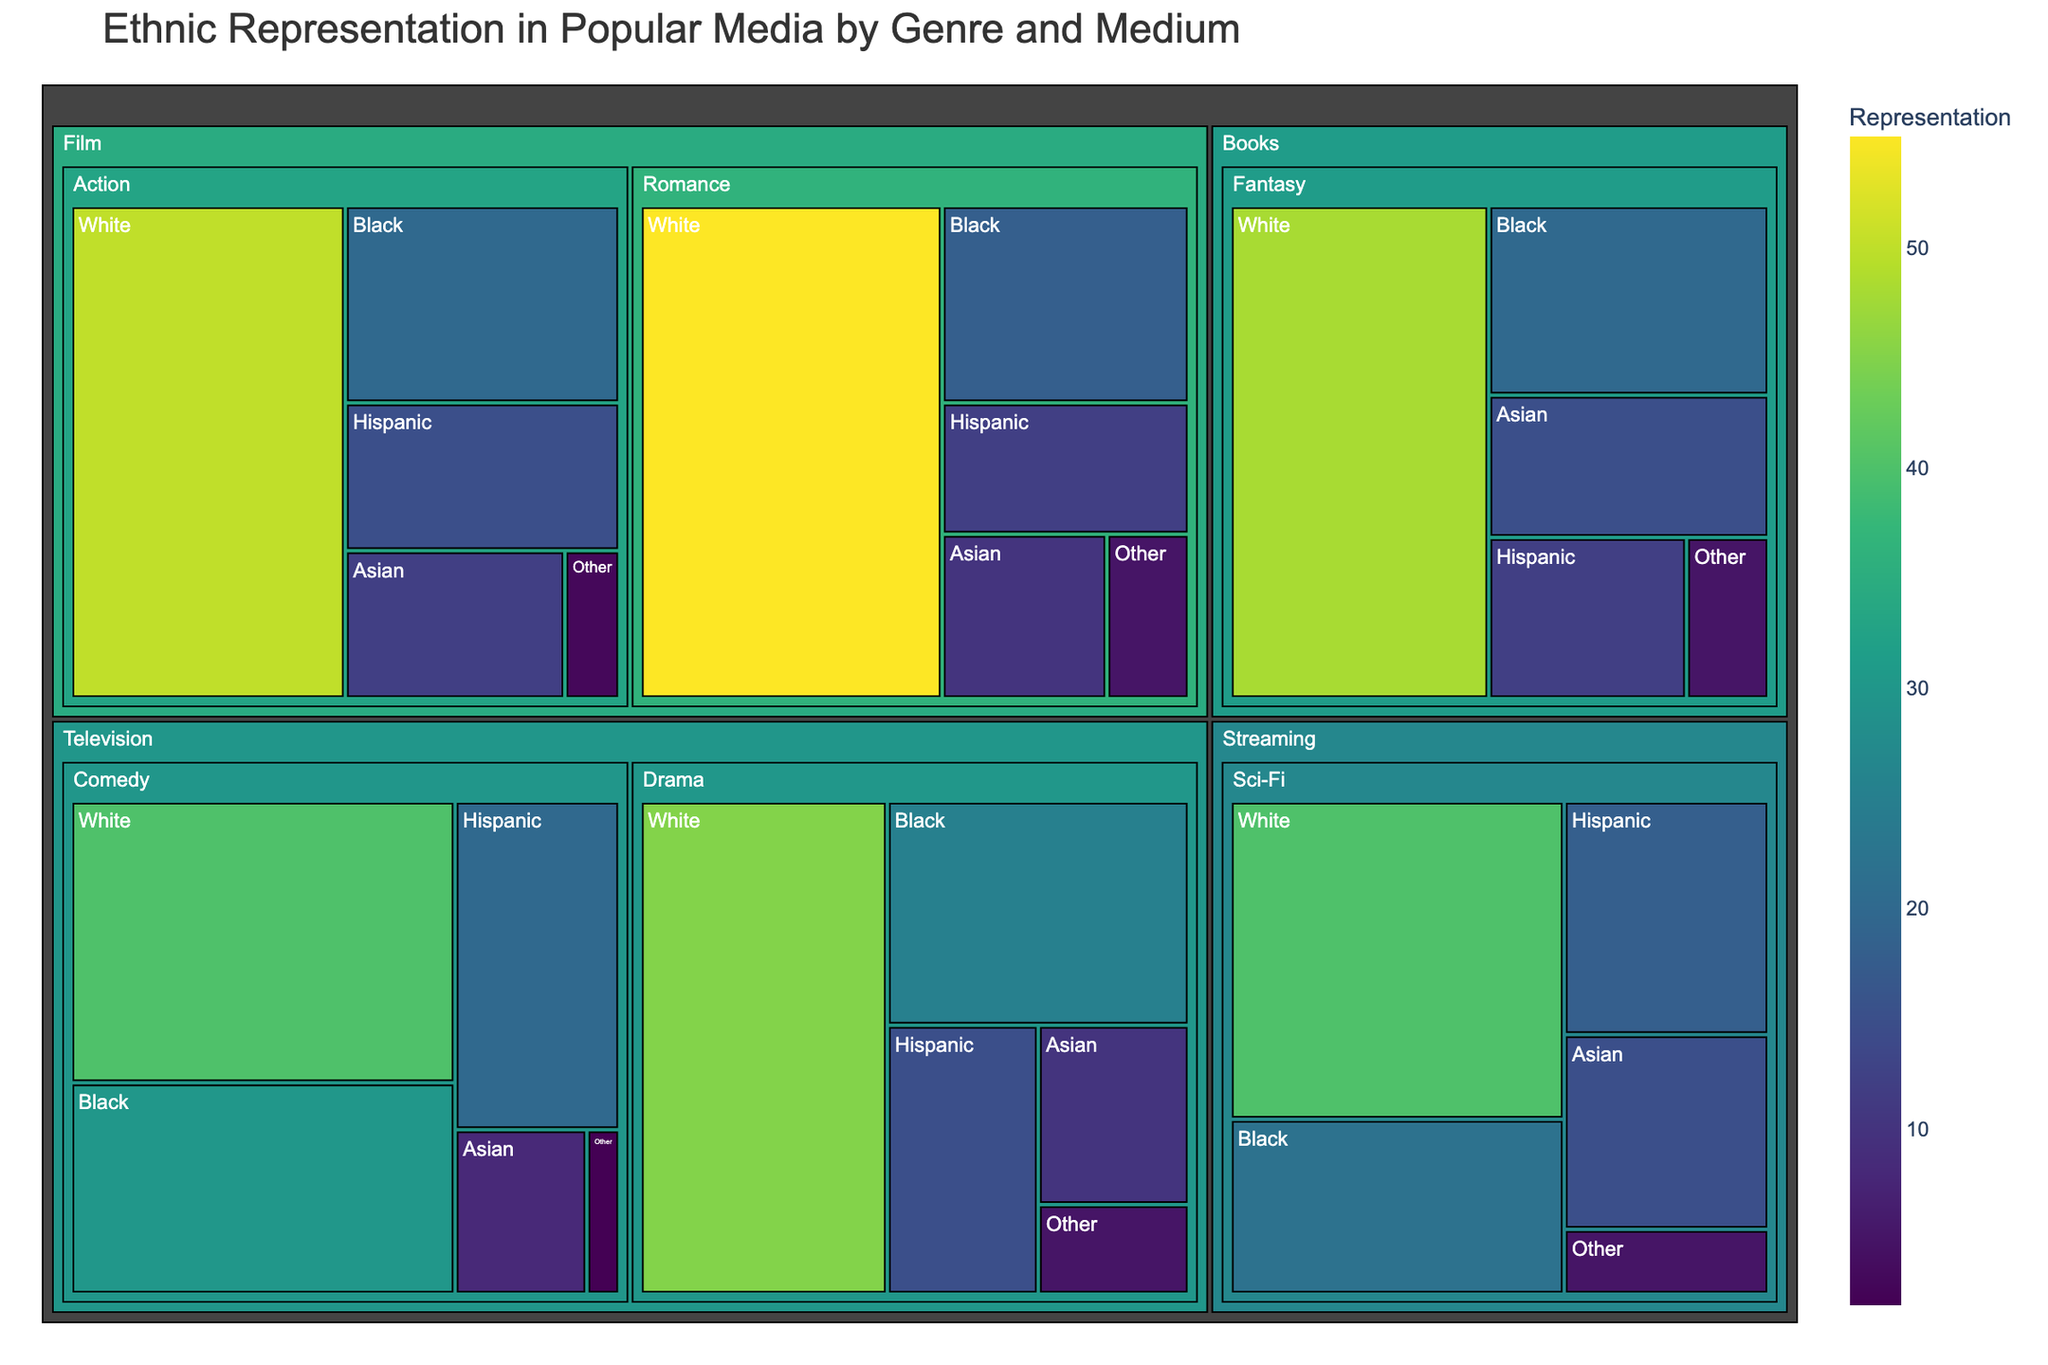What's the title of the Treemap? The title of the Treemap is usually prominently displayed at the top of the figure. It provides an overview of what the visualization represents.
Answer: Ethnic Representation in Popular Media by Genre and Medium Which ethnicity has the least representation in the Drama genre on Television? To answer this question, locate the Drama genre section under the Television medium. Then, identify the ethnicity with the smallest numerical representation.
Answer: Other What is the total representation of the Hispanic ethnicity in all genres and mediums combined? To calculate this, sum the representation values for the Hispanic ethnicity across each genre and medium as shown in the figure.
Answer: 92 Compare the representation of Black ethnicity in Romance films and Drama on Television. Which one is higher? Locate the representation values for Black ethnicity under Romance films and Drama on Television. Compare the two numerical values to identify which one is higher.
Answer: Drama on Television Which medium has the widest range of ethnic representation values? To determine this, observe each medium's highest and lowest representation values. The medium with the largest difference between these values has the widest range.
Answer: Television How does the representation of Asian ethnicity in Fantasy books compare to that in Sci-Fi streaming? Find the representation values for Asian ethnicity under Fantasy books and Sci-Fi streaming. Compare the two to see which one is greater.
Answer: Sci-Fi streaming What is the combined representation of White ethnicity in all Film genres? Sum up the representation values of the White ethnicity across all genres listed under the Film medium.
Answer: 105 Identify the genre and medium combination with the highest representation of the White ethnicity. Look at the figure and locate the largest numerical representation for White ethnicity across all genre and medium combinations.
Answer: Romance, Film How is the other ethnicity represented across different genres and mediums? Examine the sections for each genre and medium to find the representation values for the 'Other' ethnicity, then compare them across the figure.
Answer: TV Drama: 5, TV Comedy: 2, Film Action: 3, Film Romance: 5, Streaming Sci-Fi: 5, Books Fantasy: 5 Calculate the difference in representation between Black and White ethnicities in Comedy on Television. Locate the representation values for Black and White ethnicities under Comedy on Television, and subtract the Black ethnicity value from the White ethnicity value.
Answer: 10 